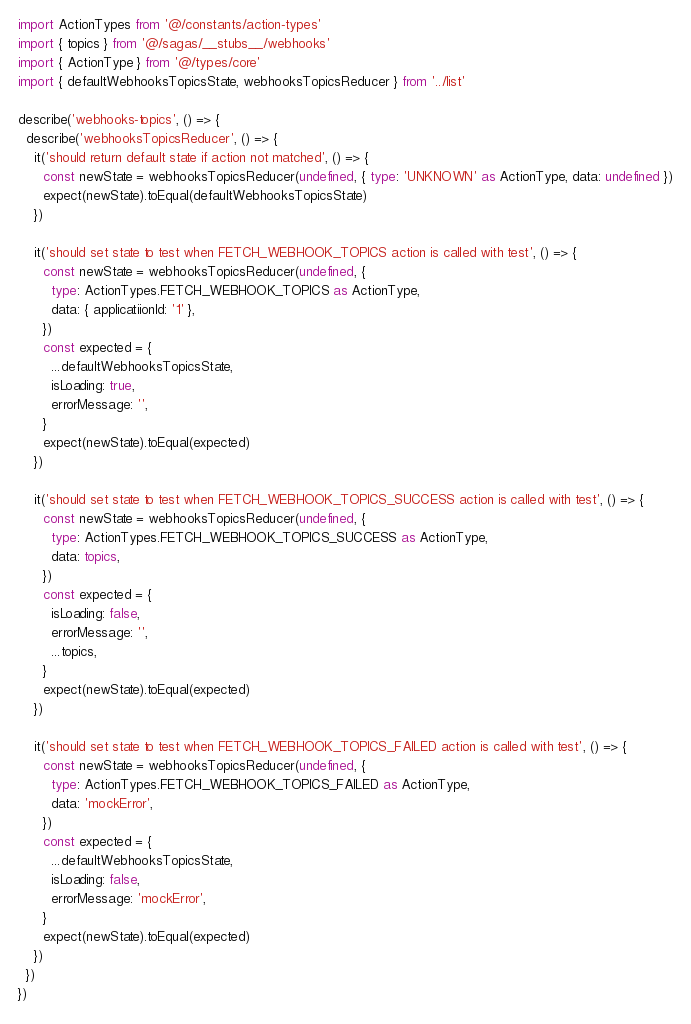Convert code to text. <code><loc_0><loc_0><loc_500><loc_500><_TypeScript_>import ActionTypes from '@/constants/action-types'
import { topics } from '@/sagas/__stubs__/webhooks'
import { ActionType } from '@/types/core'
import { defaultWebhooksTopicsState, webhooksTopicsReducer } from '../list'

describe('webhooks-topics', () => {
  describe('webhooksTopicsReducer', () => {
    it('should return default state if action not matched', () => {
      const newState = webhooksTopicsReducer(undefined, { type: 'UNKNOWN' as ActionType, data: undefined })
      expect(newState).toEqual(defaultWebhooksTopicsState)
    })

    it('should set state to test when FETCH_WEBHOOK_TOPICS action is called with test', () => {
      const newState = webhooksTopicsReducer(undefined, {
        type: ActionTypes.FETCH_WEBHOOK_TOPICS as ActionType,
        data: { applicatiionId: '1' },
      })
      const expected = {
        ...defaultWebhooksTopicsState,
        isLoading: true,
        errorMessage: '',
      }
      expect(newState).toEqual(expected)
    })

    it('should set state to test when FETCH_WEBHOOK_TOPICS_SUCCESS action is called with test', () => {
      const newState = webhooksTopicsReducer(undefined, {
        type: ActionTypes.FETCH_WEBHOOK_TOPICS_SUCCESS as ActionType,
        data: topics,
      })
      const expected = {
        isLoading: false,
        errorMessage: '',
        ...topics,
      }
      expect(newState).toEqual(expected)
    })

    it('should set state to test when FETCH_WEBHOOK_TOPICS_FAILED action is called with test', () => {
      const newState = webhooksTopicsReducer(undefined, {
        type: ActionTypes.FETCH_WEBHOOK_TOPICS_FAILED as ActionType,
        data: 'mockError',
      })
      const expected = {
        ...defaultWebhooksTopicsState,
        isLoading: false,
        errorMessage: 'mockError',
      }
      expect(newState).toEqual(expected)
    })
  })
})
</code> 